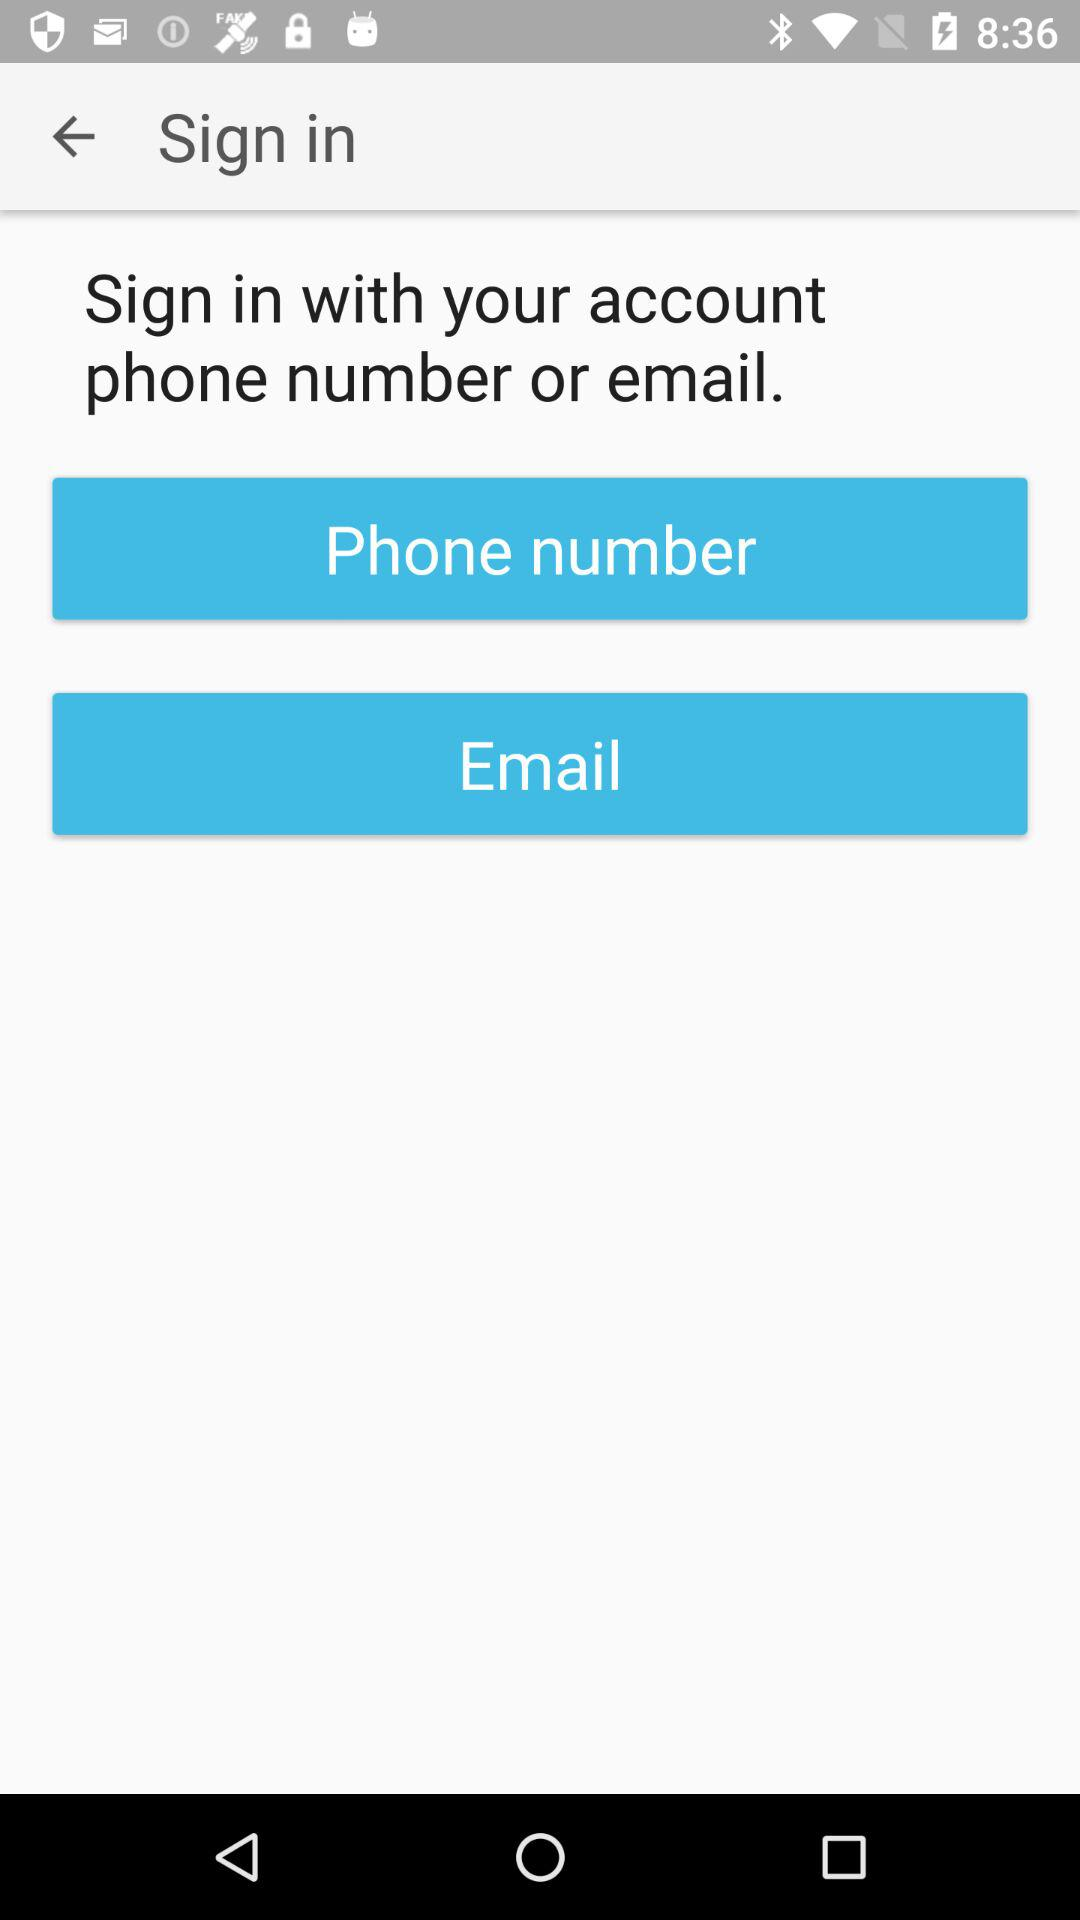What is the user's phone number and email?
When the provided information is insufficient, respond with <no answer>. <no answer> 